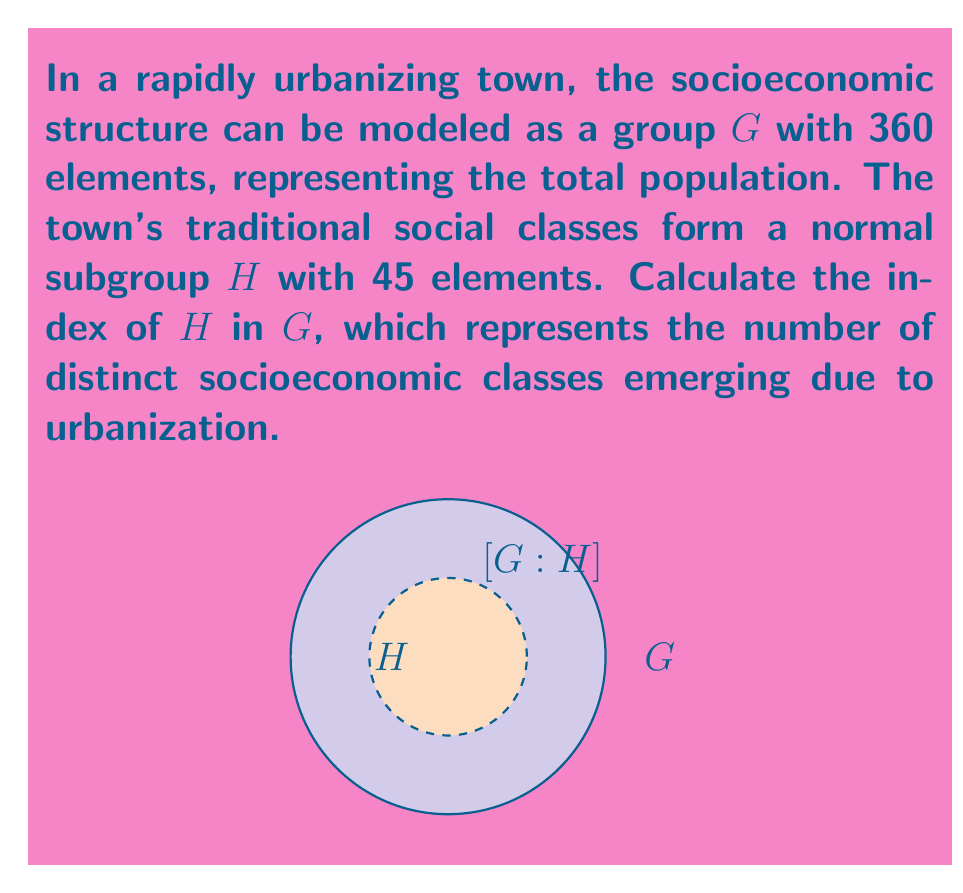Help me with this question. To solve this problem, we need to understand the concept of index in group theory and how it applies to our urbanizing society model:

1) The index of a subgroup $H$ in a group $G$, denoted as $[G:H]$, is defined as the number of distinct left (or right) cosets of $H$ in $G$.

2) For finite groups, the index is equal to the quotient of the orders of $G$ and $H$:

   $$[G:H] = \frac{|G|}{|H|}$$

3) In our case:
   - $|G| = 360$ (total population)
   - $|H| = 45$ (traditional social classes)

4) Applying the formula:

   $$[G:H] = \frac{|G|}{|H|} = \frac{360}{45}$$

5) Simplify the fraction:

   $$\frac{360}{45} = \frac{360 \div 45}{45 \div 45} = \frac{8}{1} = 8$$

Therefore, the index of $H$ in $G$ is 8, indicating that urbanization has led to the emergence of 8 distinct socioeconomic classes in the town.
Answer: $[G:H] = 8$ 